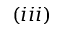Convert formula to latex. <formula><loc_0><loc_0><loc_500><loc_500>( i i i )</formula> 